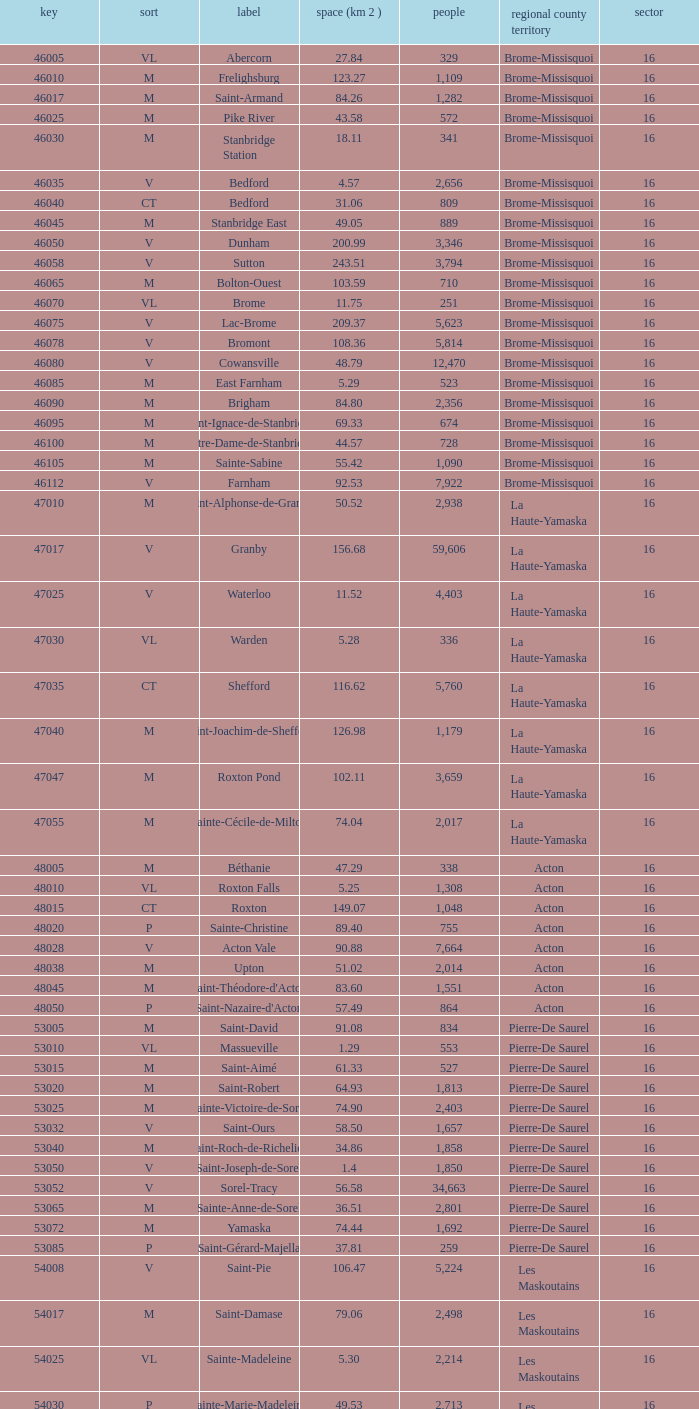Saint-Blaise-Sur-Richelieu is smaller than 68.42 km^2, what is the population of this type M municipality? None. 